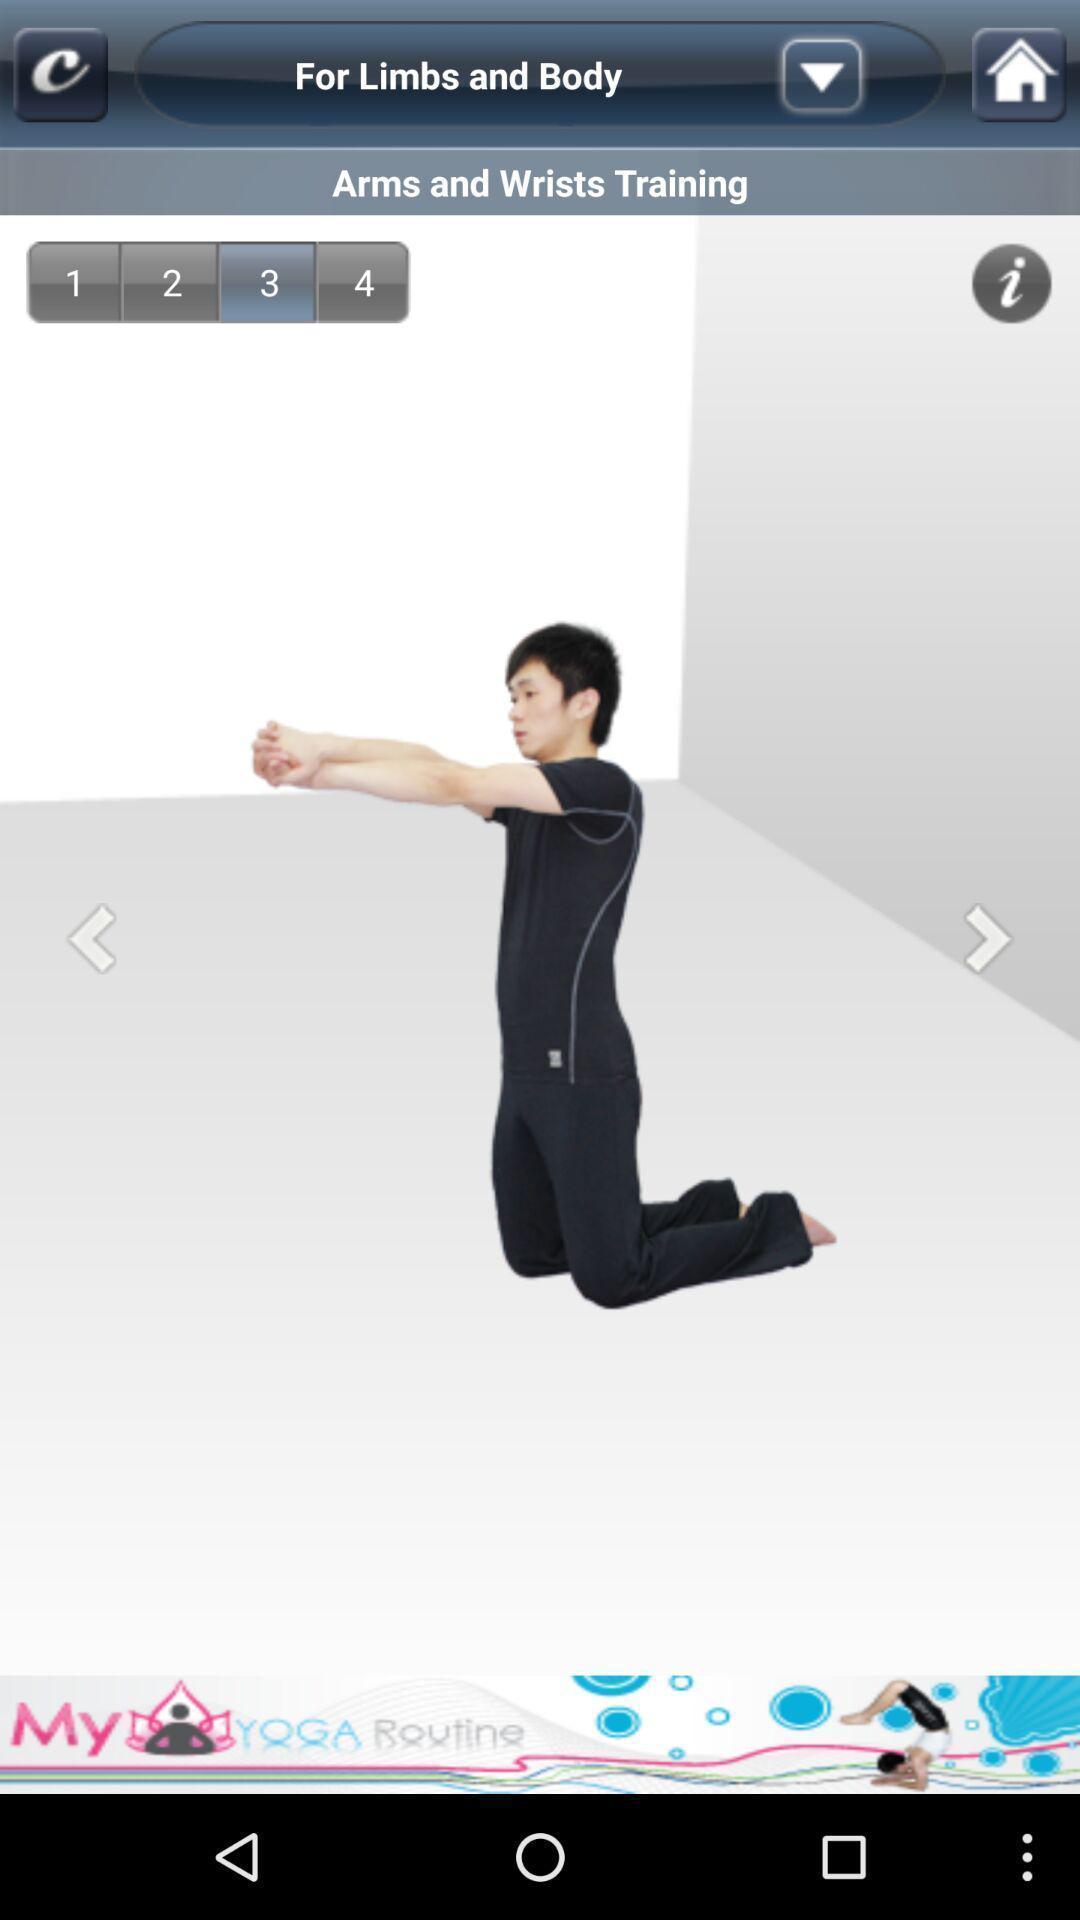Provide a detailed account of this screenshot. Screen showing exercise pose in fitness app. 